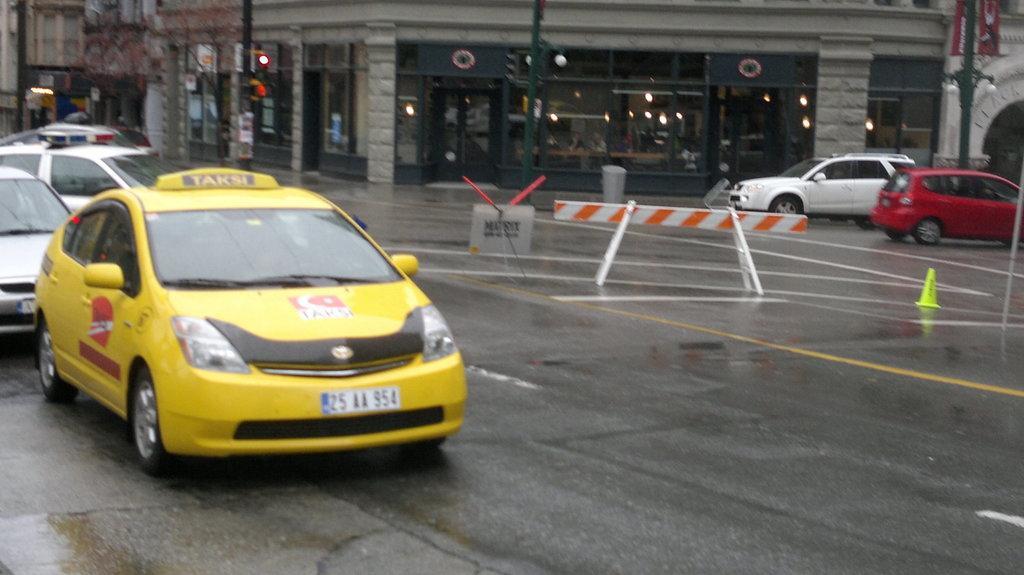How would you summarize this image in a sentence or two? In this image there is water on the road. Vehicles are moving on. There are buildings on the backside. 